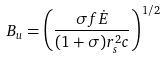Convert formula to latex. <formula><loc_0><loc_0><loc_500><loc_500>B _ { u } = \left ( \frac { \sigma f \dot { E } } { ( 1 + \sigma ) r _ { s } ^ { 2 } c } \right ) ^ { 1 / 2 }</formula> 